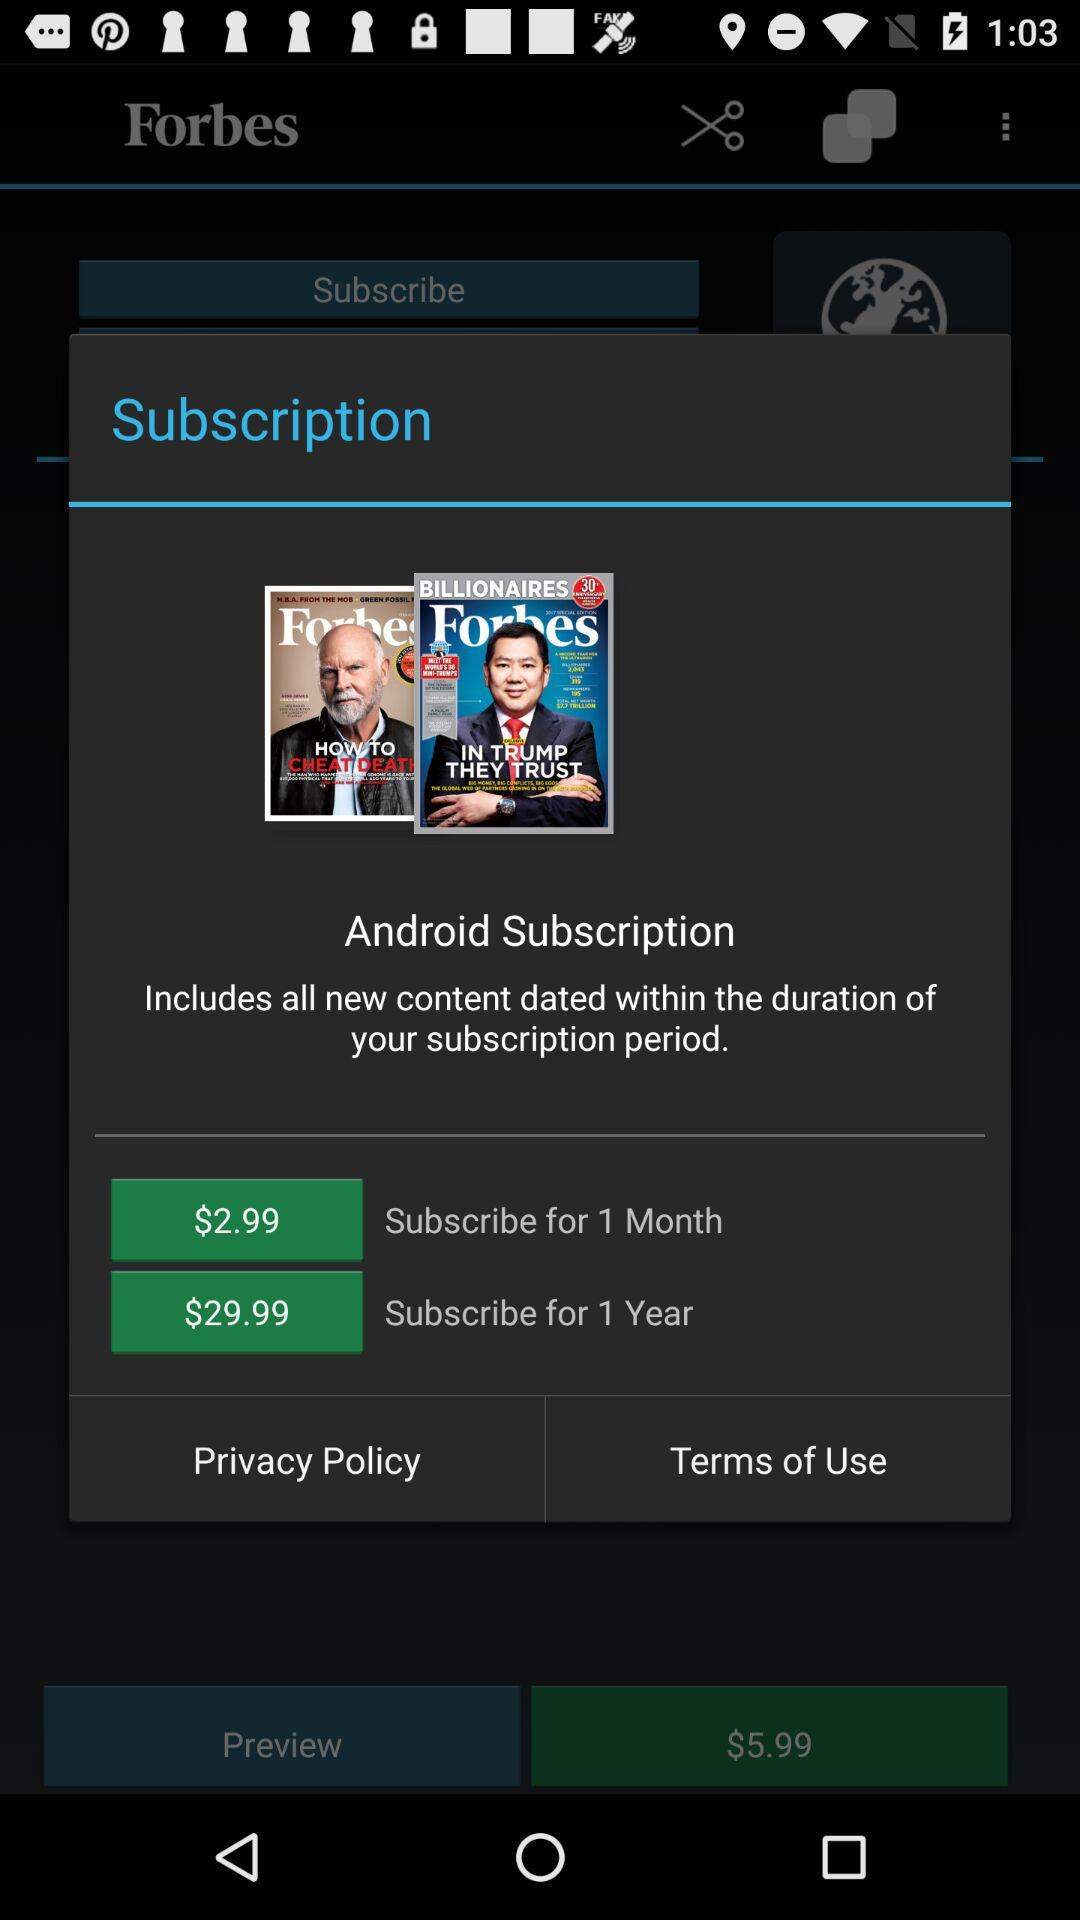How many more months of subscription does the 1 year subscription cover than the 1 month subscription?
Answer the question using a single word or phrase. 11 